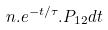Convert formula to latex. <formula><loc_0><loc_0><loc_500><loc_500>n . e ^ { - t / \tau } . P _ { 1 2 } d t</formula> 